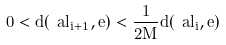Convert formula to latex. <formula><loc_0><loc_0><loc_500><loc_500>0 < d ( \ a l _ { i + 1 } , e ) < \frac { 1 } { 2 M } d ( \ a l _ { i } , e )</formula> 